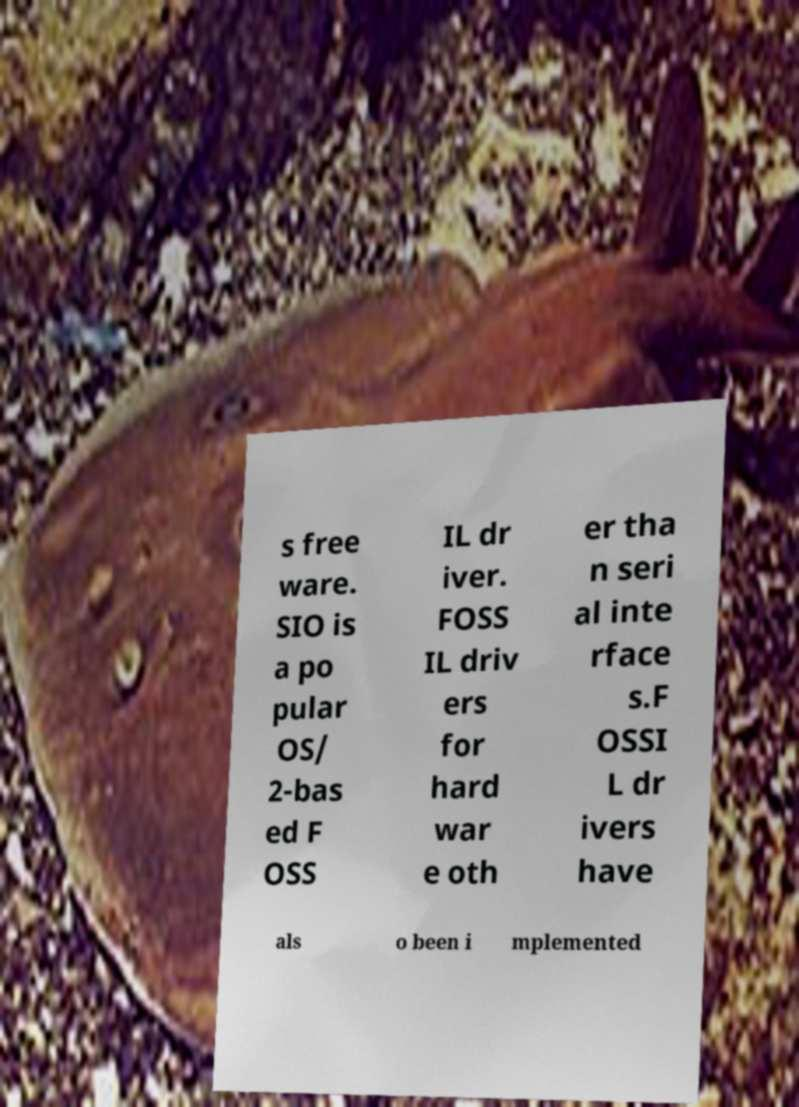Could you assist in decoding the text presented in this image and type it out clearly? s free ware. SIO is a po pular OS/ 2-bas ed F OSS IL dr iver. FOSS IL driv ers for hard war e oth er tha n seri al inte rface s.F OSSI L dr ivers have als o been i mplemented 